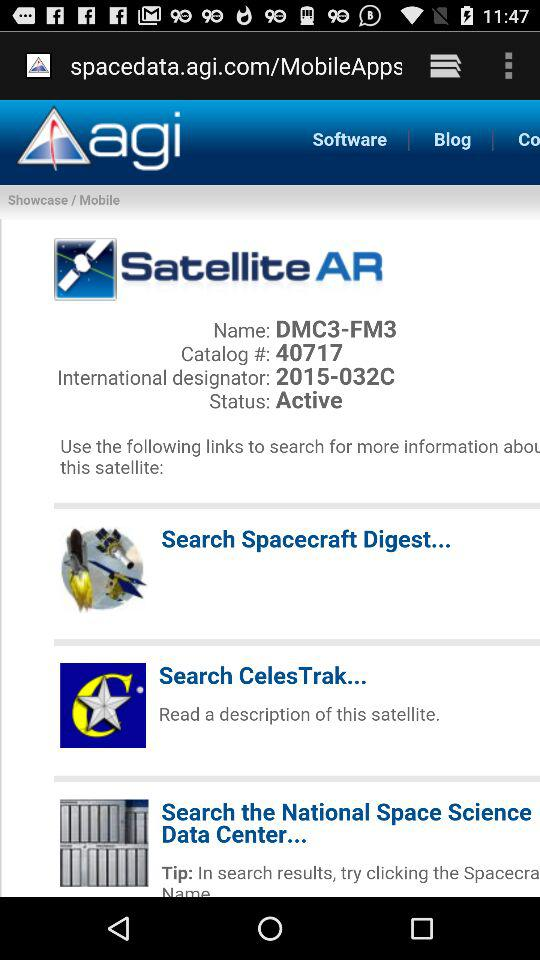When was the latest blog posted?
When the provided information is insufficient, respond with <no answer>. <no answer> 